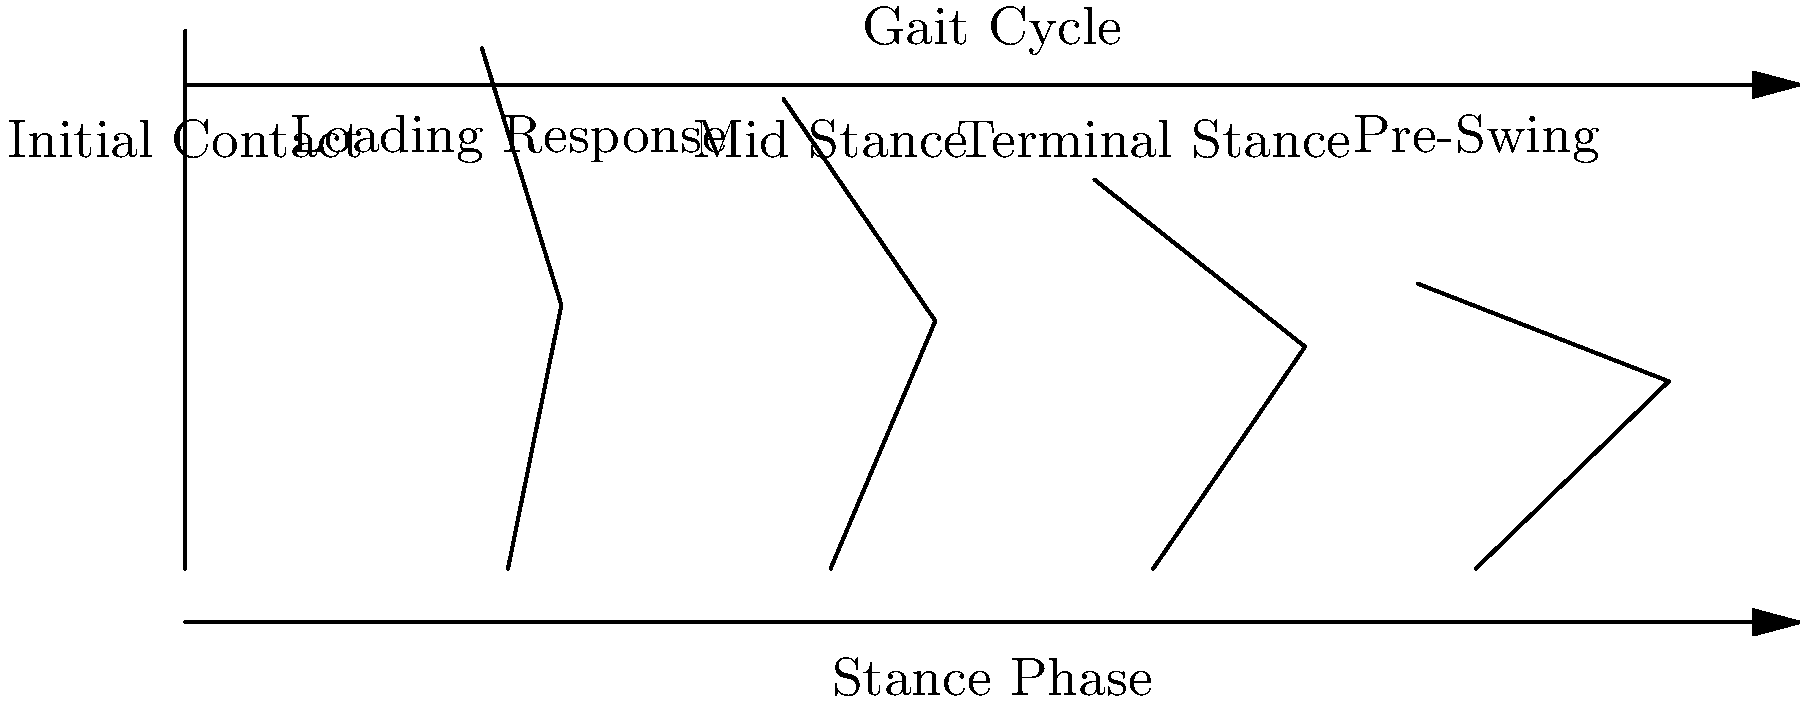In the gait cycle diagram above, which phase demonstrates the greatest degree of knee flexion, and how does this relate to the concept of holistic patient care in nursing? To answer this question, let's break down the gait cycle and its phases:

1. Initial Contact: The heel strikes the ground, and the knee is almost fully extended.

2. Loading Response: The foot becomes flat on the ground, and the knee begins to flex slightly to absorb shock.

3. Mid Stance: The body's weight is fully over the supporting leg, and the knee is slightly flexed.

4. Terminal Stance: The heel begins to rise, and the knee starts to extend again.

5. Pre-Swing: The toe is about to leave the ground, and the knee begins to flex in preparation for the swing phase.

Looking at the diagram, we can see that the greatest degree of knee flexion occurs during the Pre-Swing phase (the last stick figure in the image).

Relating this to holistic patient care in nursing:

1. Understanding biomechanics helps nurses assess patients' mobility more comprehensively.

2. Knowledge of the gait cycle allows nurses to identify potential issues in a patient's walking pattern, which may indicate underlying health problems or risks for falls.

3. By recognizing the Pre-Swing phase as a critical moment in the gait cycle, nurses can better educate patients on proper walking techniques, especially those at risk for falls or recovering from lower limb injuries.

4. This biomechanical knowledge contributes to a more holistic approach to patient care by considering not just the medical aspects but also the functional and mobility-related factors that affect a patient's overall well-being and quality of life.

5. Incorporating this understanding into patient care plans can lead to more effective rehabilitation strategies and fall prevention measures, addressing both physical and psychological aspects of patient health.
Answer: Pre-Swing phase; enhances holistic assessment of mobility, fall risk, and rehabilitation needs. 